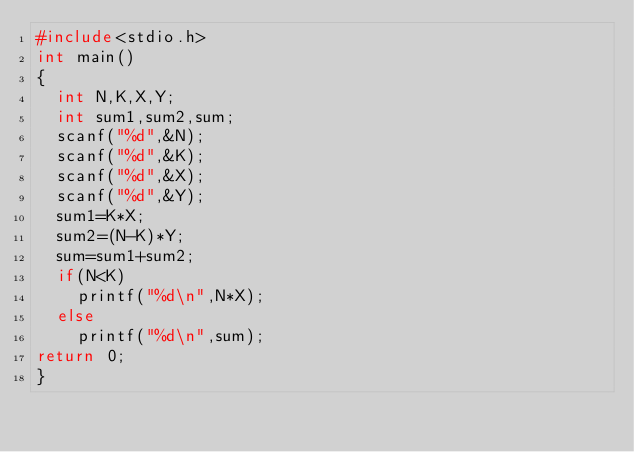Convert code to text. <code><loc_0><loc_0><loc_500><loc_500><_C++_>#include<stdio.h>
int main()
{
	int N,K,X,Y;
	int sum1,sum2,sum;
	scanf("%d",&N);
	scanf("%d",&K);
	scanf("%d",&X);
	scanf("%d",&Y);
	sum1=K*X;
	sum2=(N-K)*Y;
	sum=sum1+sum2;
	if(N<K)
		printf("%d\n",N*X);
	else
		printf("%d\n",sum);
return 0;
}
</code> 